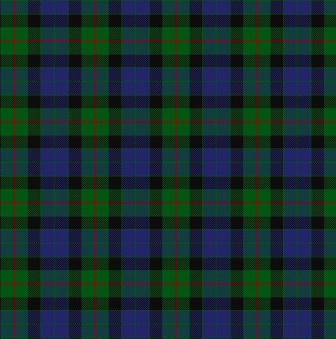If this pattern came to life, what kind of stories would it tell? Imagine if this tartan pattern could speak; it would tell tales of ancient Scottish clans, their proud histories, and courageous battles. It might narrate stories of gatherings around the hearths in highland castles, the melodies of bagpipes floating through the air, and the gentle yet resilient spirit of the Scots. Each intersection of colors would represent interconnected lives and complex relationships woven through the fabric of time, speaking of unity, identity, and heritage that has thrived through centuries. 